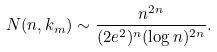Convert formula to latex. <formula><loc_0><loc_0><loc_500><loc_500>N ( n , k _ { m } ) \sim \frac { n ^ { 2 n } } { ( 2 e ^ { 2 } ) ^ { n } ( \log n ) ^ { 2 n } } .</formula> 